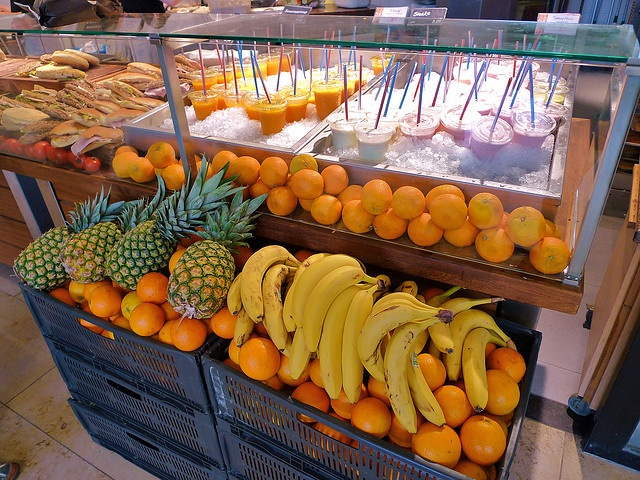Describe the objects in this image and their specific colors. I can see orange in gray, black, red, maroon, and navy tones, banana in gray, olive, and orange tones, orange in gray, red, orange, and maroon tones, banana in gray, olive, orange, and black tones, and banana in gray, orange, and olive tones in this image. 